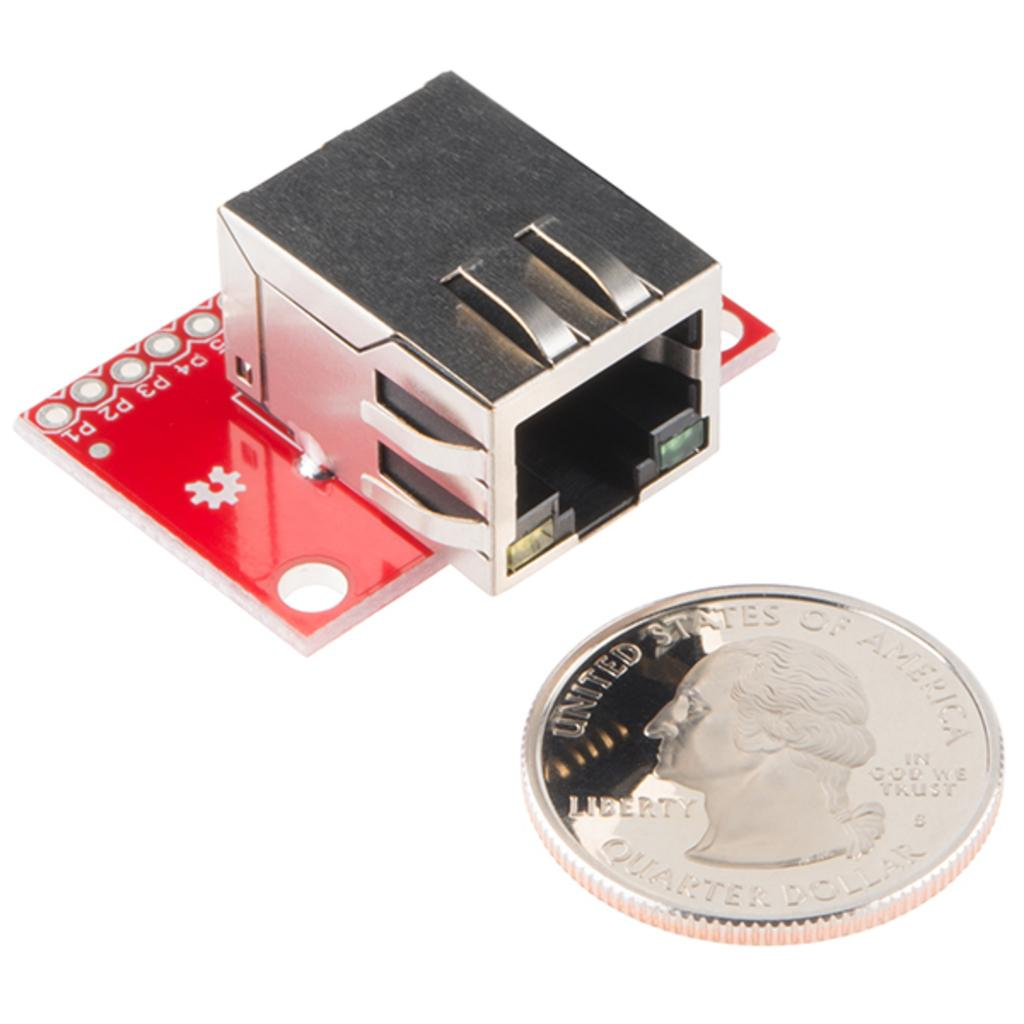Provide a one-sentence caption for the provided image. A shiny coin with "United States of America' printed at the top. 